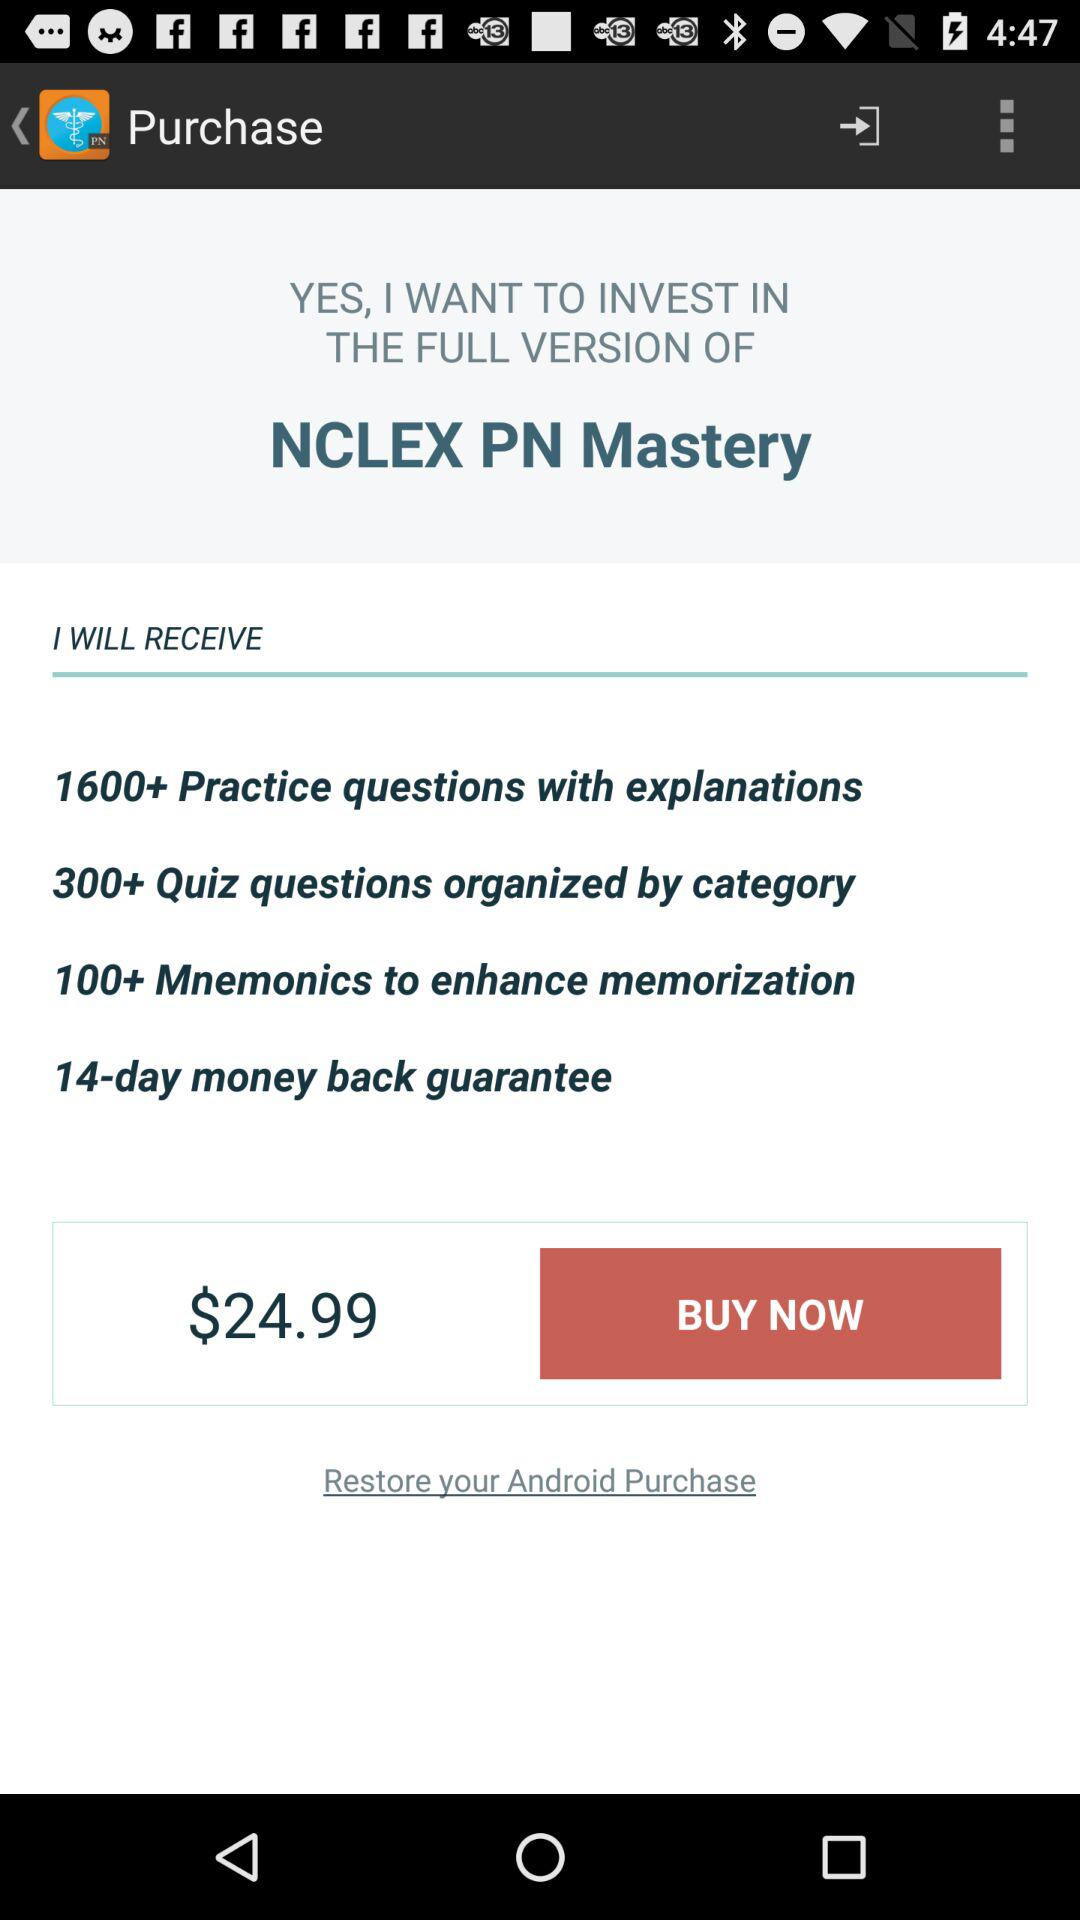How many different types of features are offered in the full version of NCLEX PN Mastery?
Answer the question using a single word or phrase. 4 